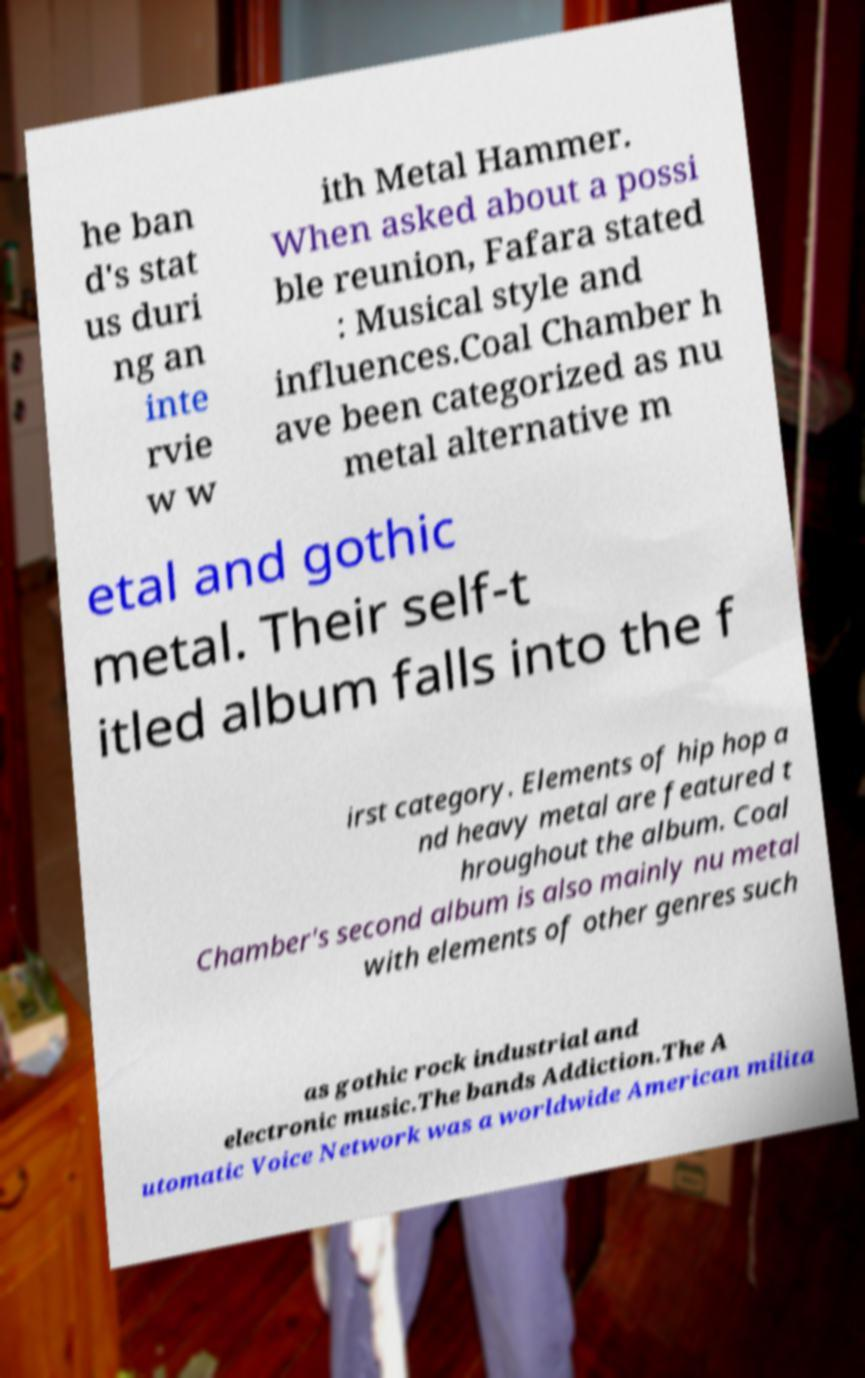I need the written content from this picture converted into text. Can you do that? he ban d's stat us duri ng an inte rvie w w ith Metal Hammer. When asked about a possi ble reunion, Fafara stated : Musical style and influences.Coal Chamber h ave been categorized as nu metal alternative m etal and gothic metal. Their self-t itled album falls into the f irst category. Elements of hip hop a nd heavy metal are featured t hroughout the album. Coal Chamber's second album is also mainly nu metal with elements of other genres such as gothic rock industrial and electronic music.The bands Addiction.The A utomatic Voice Network was a worldwide American milita 